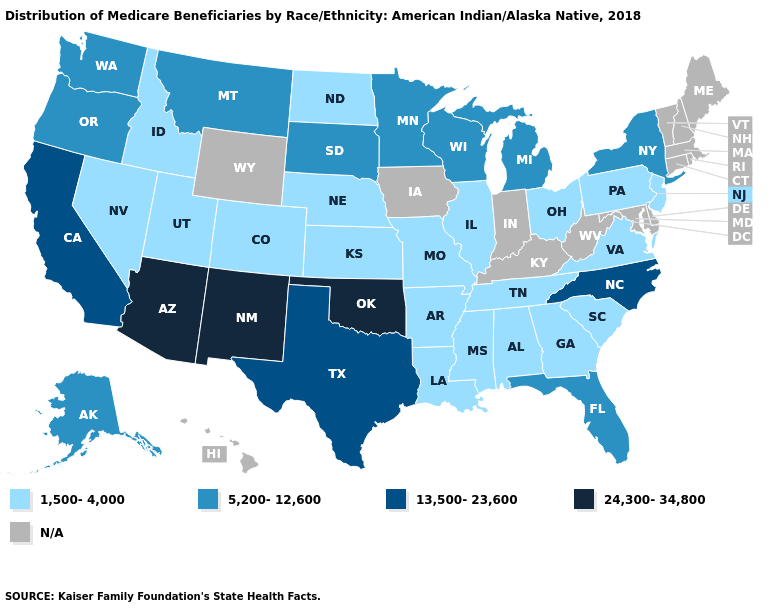Does North Carolina have the highest value in the USA?
Concise answer only. No. What is the value of North Carolina?
Quick response, please. 13,500-23,600. Name the states that have a value in the range 24,300-34,800?
Be succinct. Arizona, New Mexico, Oklahoma. Which states have the highest value in the USA?
Short answer required. Arizona, New Mexico, Oklahoma. Does New York have the highest value in the Northeast?
Be succinct. Yes. Name the states that have a value in the range 5,200-12,600?
Answer briefly. Alaska, Florida, Michigan, Minnesota, Montana, New York, Oregon, South Dakota, Washington, Wisconsin. Name the states that have a value in the range N/A?
Short answer required. Connecticut, Delaware, Hawaii, Indiana, Iowa, Kentucky, Maine, Maryland, Massachusetts, New Hampshire, Rhode Island, Vermont, West Virginia, Wyoming. Name the states that have a value in the range 5,200-12,600?
Give a very brief answer. Alaska, Florida, Michigan, Minnesota, Montana, New York, Oregon, South Dakota, Washington, Wisconsin. Name the states that have a value in the range 13,500-23,600?
Write a very short answer. California, North Carolina, Texas. Which states have the lowest value in the USA?
Keep it brief. Alabama, Arkansas, Colorado, Georgia, Idaho, Illinois, Kansas, Louisiana, Mississippi, Missouri, Nebraska, Nevada, New Jersey, North Dakota, Ohio, Pennsylvania, South Carolina, Tennessee, Utah, Virginia. What is the highest value in the South ?
Concise answer only. 24,300-34,800. What is the highest value in states that border Illinois?
Answer briefly. 5,200-12,600. Among the states that border Oregon , which have the lowest value?
Write a very short answer. Idaho, Nevada. 